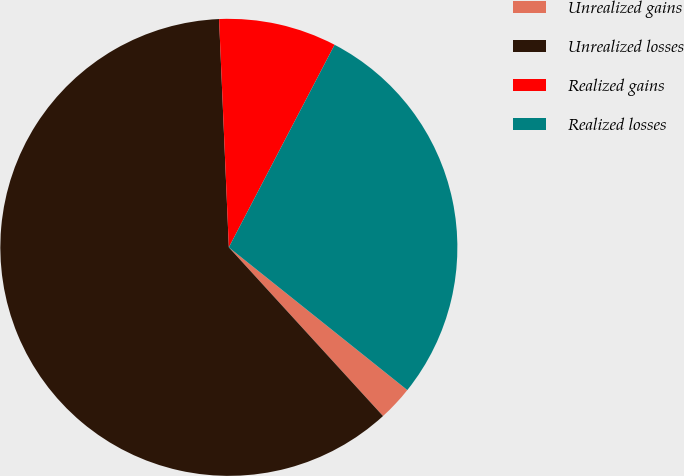<chart> <loc_0><loc_0><loc_500><loc_500><pie_chart><fcel>Unrealized gains<fcel>Unrealized losses<fcel>Realized gains<fcel>Realized losses<nl><fcel>2.48%<fcel>61.11%<fcel>8.34%<fcel>28.08%<nl></chart> 